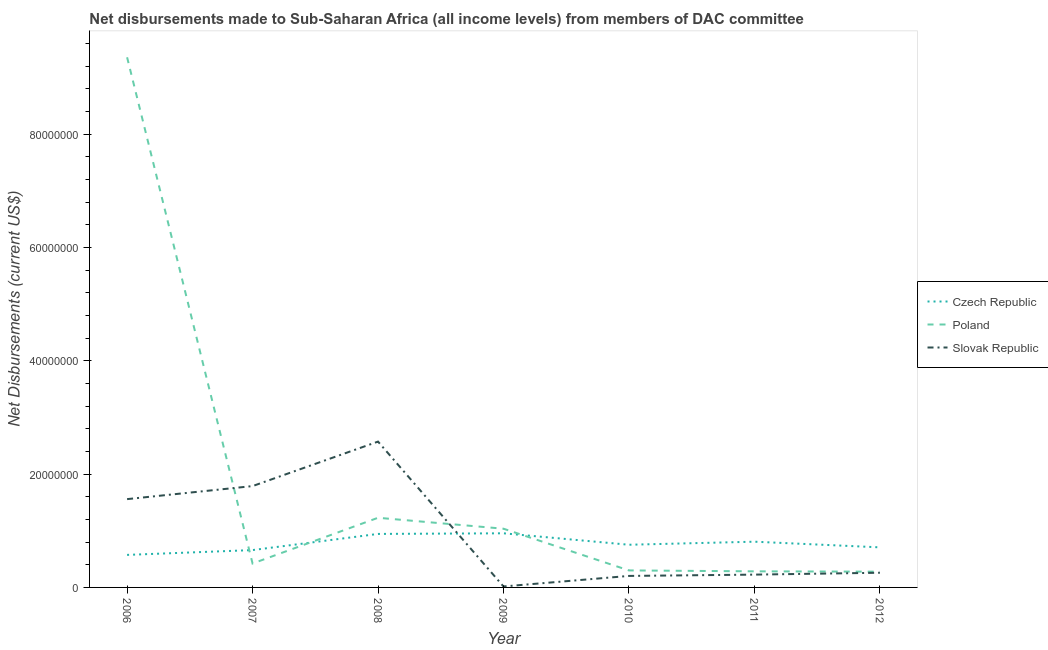Does the line corresponding to net disbursements made by slovak republic intersect with the line corresponding to net disbursements made by poland?
Your answer should be compact. Yes. What is the net disbursements made by poland in 2010?
Your answer should be very brief. 3.00e+06. Across all years, what is the maximum net disbursements made by poland?
Offer a very short reply. 9.35e+07. Across all years, what is the minimum net disbursements made by czech republic?
Your response must be concise. 5.74e+06. In which year was the net disbursements made by poland minimum?
Give a very brief answer. 2012. What is the total net disbursements made by slovak republic in the graph?
Keep it short and to the point. 6.62e+07. What is the difference between the net disbursements made by slovak republic in 2008 and that in 2012?
Your answer should be compact. 2.31e+07. What is the difference between the net disbursements made by poland in 2010 and the net disbursements made by czech republic in 2011?
Your response must be concise. -5.07e+06. What is the average net disbursements made by poland per year?
Your response must be concise. 1.84e+07. In the year 2006, what is the difference between the net disbursements made by czech republic and net disbursements made by slovak republic?
Keep it short and to the point. -9.84e+06. What is the ratio of the net disbursements made by slovak republic in 2007 to that in 2008?
Keep it short and to the point. 0.69. Is the difference between the net disbursements made by czech republic in 2006 and 2012 greater than the difference between the net disbursements made by slovak republic in 2006 and 2012?
Provide a succinct answer. No. What is the difference between the highest and the second highest net disbursements made by slovak republic?
Give a very brief answer. 7.85e+06. What is the difference between the highest and the lowest net disbursements made by poland?
Keep it short and to the point. 9.08e+07. In how many years, is the net disbursements made by czech republic greater than the average net disbursements made by czech republic taken over all years?
Your answer should be very brief. 3. Does the net disbursements made by slovak republic monotonically increase over the years?
Offer a terse response. No. Is the net disbursements made by slovak republic strictly greater than the net disbursements made by czech republic over the years?
Provide a short and direct response. No. Is the net disbursements made by slovak republic strictly less than the net disbursements made by czech republic over the years?
Offer a very short reply. No. How many years are there in the graph?
Your answer should be compact. 7. What is the difference between two consecutive major ticks on the Y-axis?
Your answer should be compact. 2.00e+07. Are the values on the major ticks of Y-axis written in scientific E-notation?
Keep it short and to the point. No. Does the graph contain any zero values?
Keep it short and to the point. No. How many legend labels are there?
Offer a terse response. 3. What is the title of the graph?
Your answer should be compact. Net disbursements made to Sub-Saharan Africa (all income levels) from members of DAC committee. What is the label or title of the Y-axis?
Offer a terse response. Net Disbursements (current US$). What is the Net Disbursements (current US$) in Czech Republic in 2006?
Keep it short and to the point. 5.74e+06. What is the Net Disbursements (current US$) in Poland in 2006?
Ensure brevity in your answer.  9.35e+07. What is the Net Disbursements (current US$) in Slovak Republic in 2006?
Provide a short and direct response. 1.56e+07. What is the Net Disbursements (current US$) in Czech Republic in 2007?
Your answer should be very brief. 6.59e+06. What is the Net Disbursements (current US$) in Poland in 2007?
Provide a succinct answer. 4.22e+06. What is the Net Disbursements (current US$) of Slovak Republic in 2007?
Offer a terse response. 1.79e+07. What is the Net Disbursements (current US$) of Czech Republic in 2008?
Make the answer very short. 9.44e+06. What is the Net Disbursements (current US$) in Poland in 2008?
Make the answer very short. 1.23e+07. What is the Net Disbursements (current US$) of Slovak Republic in 2008?
Offer a terse response. 2.57e+07. What is the Net Disbursements (current US$) in Czech Republic in 2009?
Keep it short and to the point. 9.55e+06. What is the Net Disbursements (current US$) of Poland in 2009?
Provide a short and direct response. 1.04e+07. What is the Net Disbursements (current US$) in Slovak Republic in 2009?
Ensure brevity in your answer.  1.70e+05. What is the Net Disbursements (current US$) in Czech Republic in 2010?
Offer a very short reply. 7.53e+06. What is the Net Disbursements (current US$) of Slovak Republic in 2010?
Offer a terse response. 2.03e+06. What is the Net Disbursements (current US$) in Czech Republic in 2011?
Provide a succinct answer. 8.07e+06. What is the Net Disbursements (current US$) of Poland in 2011?
Provide a short and direct response. 2.84e+06. What is the Net Disbursements (current US$) in Slovak Republic in 2011?
Your answer should be compact. 2.26e+06. What is the Net Disbursements (current US$) in Czech Republic in 2012?
Keep it short and to the point. 7.07e+06. What is the Net Disbursements (current US$) of Poland in 2012?
Your response must be concise. 2.78e+06. What is the Net Disbursements (current US$) of Slovak Republic in 2012?
Provide a succinct answer. 2.59e+06. Across all years, what is the maximum Net Disbursements (current US$) in Czech Republic?
Give a very brief answer. 9.55e+06. Across all years, what is the maximum Net Disbursements (current US$) of Poland?
Make the answer very short. 9.35e+07. Across all years, what is the maximum Net Disbursements (current US$) of Slovak Republic?
Your answer should be very brief. 2.57e+07. Across all years, what is the minimum Net Disbursements (current US$) in Czech Republic?
Your answer should be compact. 5.74e+06. Across all years, what is the minimum Net Disbursements (current US$) of Poland?
Provide a succinct answer. 2.78e+06. Across all years, what is the minimum Net Disbursements (current US$) in Slovak Republic?
Offer a very short reply. 1.70e+05. What is the total Net Disbursements (current US$) in Czech Republic in the graph?
Offer a terse response. 5.40e+07. What is the total Net Disbursements (current US$) of Poland in the graph?
Your answer should be compact. 1.29e+08. What is the total Net Disbursements (current US$) of Slovak Republic in the graph?
Give a very brief answer. 6.62e+07. What is the difference between the Net Disbursements (current US$) in Czech Republic in 2006 and that in 2007?
Your response must be concise. -8.50e+05. What is the difference between the Net Disbursements (current US$) of Poland in 2006 and that in 2007?
Your response must be concise. 8.93e+07. What is the difference between the Net Disbursements (current US$) in Slovak Republic in 2006 and that in 2007?
Give a very brief answer. -2.30e+06. What is the difference between the Net Disbursements (current US$) in Czech Republic in 2006 and that in 2008?
Provide a short and direct response. -3.70e+06. What is the difference between the Net Disbursements (current US$) of Poland in 2006 and that in 2008?
Offer a terse response. 8.12e+07. What is the difference between the Net Disbursements (current US$) of Slovak Republic in 2006 and that in 2008?
Your answer should be very brief. -1.02e+07. What is the difference between the Net Disbursements (current US$) in Czech Republic in 2006 and that in 2009?
Ensure brevity in your answer.  -3.81e+06. What is the difference between the Net Disbursements (current US$) of Poland in 2006 and that in 2009?
Your answer should be compact. 8.32e+07. What is the difference between the Net Disbursements (current US$) of Slovak Republic in 2006 and that in 2009?
Ensure brevity in your answer.  1.54e+07. What is the difference between the Net Disbursements (current US$) in Czech Republic in 2006 and that in 2010?
Your response must be concise. -1.79e+06. What is the difference between the Net Disbursements (current US$) in Poland in 2006 and that in 2010?
Offer a very short reply. 9.05e+07. What is the difference between the Net Disbursements (current US$) in Slovak Republic in 2006 and that in 2010?
Offer a terse response. 1.36e+07. What is the difference between the Net Disbursements (current US$) of Czech Republic in 2006 and that in 2011?
Your answer should be very brief. -2.33e+06. What is the difference between the Net Disbursements (current US$) of Poland in 2006 and that in 2011?
Provide a succinct answer. 9.07e+07. What is the difference between the Net Disbursements (current US$) of Slovak Republic in 2006 and that in 2011?
Provide a short and direct response. 1.33e+07. What is the difference between the Net Disbursements (current US$) of Czech Republic in 2006 and that in 2012?
Your response must be concise. -1.33e+06. What is the difference between the Net Disbursements (current US$) in Poland in 2006 and that in 2012?
Make the answer very short. 9.08e+07. What is the difference between the Net Disbursements (current US$) in Slovak Republic in 2006 and that in 2012?
Ensure brevity in your answer.  1.30e+07. What is the difference between the Net Disbursements (current US$) in Czech Republic in 2007 and that in 2008?
Give a very brief answer. -2.85e+06. What is the difference between the Net Disbursements (current US$) in Poland in 2007 and that in 2008?
Your answer should be very brief. -8.07e+06. What is the difference between the Net Disbursements (current US$) of Slovak Republic in 2007 and that in 2008?
Provide a short and direct response. -7.85e+06. What is the difference between the Net Disbursements (current US$) of Czech Republic in 2007 and that in 2009?
Give a very brief answer. -2.96e+06. What is the difference between the Net Disbursements (current US$) in Poland in 2007 and that in 2009?
Your answer should be very brief. -6.14e+06. What is the difference between the Net Disbursements (current US$) in Slovak Republic in 2007 and that in 2009?
Ensure brevity in your answer.  1.77e+07. What is the difference between the Net Disbursements (current US$) of Czech Republic in 2007 and that in 2010?
Provide a succinct answer. -9.40e+05. What is the difference between the Net Disbursements (current US$) of Poland in 2007 and that in 2010?
Provide a succinct answer. 1.22e+06. What is the difference between the Net Disbursements (current US$) of Slovak Republic in 2007 and that in 2010?
Make the answer very short. 1.58e+07. What is the difference between the Net Disbursements (current US$) in Czech Republic in 2007 and that in 2011?
Provide a succinct answer. -1.48e+06. What is the difference between the Net Disbursements (current US$) of Poland in 2007 and that in 2011?
Provide a succinct answer. 1.38e+06. What is the difference between the Net Disbursements (current US$) of Slovak Republic in 2007 and that in 2011?
Keep it short and to the point. 1.56e+07. What is the difference between the Net Disbursements (current US$) of Czech Republic in 2007 and that in 2012?
Ensure brevity in your answer.  -4.80e+05. What is the difference between the Net Disbursements (current US$) in Poland in 2007 and that in 2012?
Your response must be concise. 1.44e+06. What is the difference between the Net Disbursements (current US$) in Slovak Republic in 2007 and that in 2012?
Offer a terse response. 1.53e+07. What is the difference between the Net Disbursements (current US$) in Czech Republic in 2008 and that in 2009?
Provide a succinct answer. -1.10e+05. What is the difference between the Net Disbursements (current US$) of Poland in 2008 and that in 2009?
Give a very brief answer. 1.93e+06. What is the difference between the Net Disbursements (current US$) in Slovak Republic in 2008 and that in 2009?
Offer a terse response. 2.56e+07. What is the difference between the Net Disbursements (current US$) of Czech Republic in 2008 and that in 2010?
Keep it short and to the point. 1.91e+06. What is the difference between the Net Disbursements (current US$) of Poland in 2008 and that in 2010?
Your answer should be compact. 9.29e+06. What is the difference between the Net Disbursements (current US$) in Slovak Republic in 2008 and that in 2010?
Ensure brevity in your answer.  2.37e+07. What is the difference between the Net Disbursements (current US$) of Czech Republic in 2008 and that in 2011?
Your response must be concise. 1.37e+06. What is the difference between the Net Disbursements (current US$) of Poland in 2008 and that in 2011?
Provide a succinct answer. 9.45e+06. What is the difference between the Net Disbursements (current US$) in Slovak Republic in 2008 and that in 2011?
Give a very brief answer. 2.35e+07. What is the difference between the Net Disbursements (current US$) in Czech Republic in 2008 and that in 2012?
Your answer should be very brief. 2.37e+06. What is the difference between the Net Disbursements (current US$) in Poland in 2008 and that in 2012?
Give a very brief answer. 9.51e+06. What is the difference between the Net Disbursements (current US$) in Slovak Republic in 2008 and that in 2012?
Your answer should be compact. 2.31e+07. What is the difference between the Net Disbursements (current US$) in Czech Republic in 2009 and that in 2010?
Provide a succinct answer. 2.02e+06. What is the difference between the Net Disbursements (current US$) of Poland in 2009 and that in 2010?
Offer a very short reply. 7.36e+06. What is the difference between the Net Disbursements (current US$) in Slovak Republic in 2009 and that in 2010?
Provide a short and direct response. -1.86e+06. What is the difference between the Net Disbursements (current US$) in Czech Republic in 2009 and that in 2011?
Offer a very short reply. 1.48e+06. What is the difference between the Net Disbursements (current US$) in Poland in 2009 and that in 2011?
Your answer should be compact. 7.52e+06. What is the difference between the Net Disbursements (current US$) in Slovak Republic in 2009 and that in 2011?
Give a very brief answer. -2.09e+06. What is the difference between the Net Disbursements (current US$) in Czech Republic in 2009 and that in 2012?
Give a very brief answer. 2.48e+06. What is the difference between the Net Disbursements (current US$) in Poland in 2009 and that in 2012?
Offer a very short reply. 7.58e+06. What is the difference between the Net Disbursements (current US$) in Slovak Republic in 2009 and that in 2012?
Provide a short and direct response. -2.42e+06. What is the difference between the Net Disbursements (current US$) of Czech Republic in 2010 and that in 2011?
Offer a very short reply. -5.40e+05. What is the difference between the Net Disbursements (current US$) of Poland in 2010 and that in 2012?
Your answer should be compact. 2.20e+05. What is the difference between the Net Disbursements (current US$) in Slovak Republic in 2010 and that in 2012?
Ensure brevity in your answer.  -5.60e+05. What is the difference between the Net Disbursements (current US$) in Czech Republic in 2011 and that in 2012?
Give a very brief answer. 1.00e+06. What is the difference between the Net Disbursements (current US$) of Poland in 2011 and that in 2012?
Keep it short and to the point. 6.00e+04. What is the difference between the Net Disbursements (current US$) of Slovak Republic in 2011 and that in 2012?
Ensure brevity in your answer.  -3.30e+05. What is the difference between the Net Disbursements (current US$) in Czech Republic in 2006 and the Net Disbursements (current US$) in Poland in 2007?
Give a very brief answer. 1.52e+06. What is the difference between the Net Disbursements (current US$) in Czech Republic in 2006 and the Net Disbursements (current US$) in Slovak Republic in 2007?
Make the answer very short. -1.21e+07. What is the difference between the Net Disbursements (current US$) in Poland in 2006 and the Net Disbursements (current US$) in Slovak Republic in 2007?
Provide a succinct answer. 7.57e+07. What is the difference between the Net Disbursements (current US$) of Czech Republic in 2006 and the Net Disbursements (current US$) of Poland in 2008?
Offer a terse response. -6.55e+06. What is the difference between the Net Disbursements (current US$) in Czech Republic in 2006 and the Net Disbursements (current US$) in Slovak Republic in 2008?
Keep it short and to the point. -2.00e+07. What is the difference between the Net Disbursements (current US$) of Poland in 2006 and the Net Disbursements (current US$) of Slovak Republic in 2008?
Your response must be concise. 6.78e+07. What is the difference between the Net Disbursements (current US$) in Czech Republic in 2006 and the Net Disbursements (current US$) in Poland in 2009?
Offer a terse response. -4.62e+06. What is the difference between the Net Disbursements (current US$) of Czech Republic in 2006 and the Net Disbursements (current US$) of Slovak Republic in 2009?
Keep it short and to the point. 5.57e+06. What is the difference between the Net Disbursements (current US$) of Poland in 2006 and the Net Disbursements (current US$) of Slovak Republic in 2009?
Keep it short and to the point. 9.34e+07. What is the difference between the Net Disbursements (current US$) of Czech Republic in 2006 and the Net Disbursements (current US$) of Poland in 2010?
Your response must be concise. 2.74e+06. What is the difference between the Net Disbursements (current US$) in Czech Republic in 2006 and the Net Disbursements (current US$) in Slovak Republic in 2010?
Make the answer very short. 3.71e+06. What is the difference between the Net Disbursements (current US$) of Poland in 2006 and the Net Disbursements (current US$) of Slovak Republic in 2010?
Ensure brevity in your answer.  9.15e+07. What is the difference between the Net Disbursements (current US$) in Czech Republic in 2006 and the Net Disbursements (current US$) in Poland in 2011?
Give a very brief answer. 2.90e+06. What is the difference between the Net Disbursements (current US$) of Czech Republic in 2006 and the Net Disbursements (current US$) of Slovak Republic in 2011?
Give a very brief answer. 3.48e+06. What is the difference between the Net Disbursements (current US$) of Poland in 2006 and the Net Disbursements (current US$) of Slovak Republic in 2011?
Offer a terse response. 9.13e+07. What is the difference between the Net Disbursements (current US$) in Czech Republic in 2006 and the Net Disbursements (current US$) in Poland in 2012?
Ensure brevity in your answer.  2.96e+06. What is the difference between the Net Disbursements (current US$) of Czech Republic in 2006 and the Net Disbursements (current US$) of Slovak Republic in 2012?
Your answer should be compact. 3.15e+06. What is the difference between the Net Disbursements (current US$) in Poland in 2006 and the Net Disbursements (current US$) in Slovak Republic in 2012?
Your answer should be compact. 9.10e+07. What is the difference between the Net Disbursements (current US$) in Czech Republic in 2007 and the Net Disbursements (current US$) in Poland in 2008?
Your response must be concise. -5.70e+06. What is the difference between the Net Disbursements (current US$) in Czech Republic in 2007 and the Net Disbursements (current US$) in Slovak Republic in 2008?
Give a very brief answer. -1.91e+07. What is the difference between the Net Disbursements (current US$) of Poland in 2007 and the Net Disbursements (current US$) of Slovak Republic in 2008?
Provide a short and direct response. -2.15e+07. What is the difference between the Net Disbursements (current US$) in Czech Republic in 2007 and the Net Disbursements (current US$) in Poland in 2009?
Provide a succinct answer. -3.77e+06. What is the difference between the Net Disbursements (current US$) in Czech Republic in 2007 and the Net Disbursements (current US$) in Slovak Republic in 2009?
Offer a very short reply. 6.42e+06. What is the difference between the Net Disbursements (current US$) in Poland in 2007 and the Net Disbursements (current US$) in Slovak Republic in 2009?
Give a very brief answer. 4.05e+06. What is the difference between the Net Disbursements (current US$) in Czech Republic in 2007 and the Net Disbursements (current US$) in Poland in 2010?
Offer a very short reply. 3.59e+06. What is the difference between the Net Disbursements (current US$) in Czech Republic in 2007 and the Net Disbursements (current US$) in Slovak Republic in 2010?
Offer a terse response. 4.56e+06. What is the difference between the Net Disbursements (current US$) in Poland in 2007 and the Net Disbursements (current US$) in Slovak Republic in 2010?
Keep it short and to the point. 2.19e+06. What is the difference between the Net Disbursements (current US$) of Czech Republic in 2007 and the Net Disbursements (current US$) of Poland in 2011?
Provide a short and direct response. 3.75e+06. What is the difference between the Net Disbursements (current US$) in Czech Republic in 2007 and the Net Disbursements (current US$) in Slovak Republic in 2011?
Offer a terse response. 4.33e+06. What is the difference between the Net Disbursements (current US$) in Poland in 2007 and the Net Disbursements (current US$) in Slovak Republic in 2011?
Offer a terse response. 1.96e+06. What is the difference between the Net Disbursements (current US$) of Czech Republic in 2007 and the Net Disbursements (current US$) of Poland in 2012?
Ensure brevity in your answer.  3.81e+06. What is the difference between the Net Disbursements (current US$) of Czech Republic in 2007 and the Net Disbursements (current US$) of Slovak Republic in 2012?
Your answer should be compact. 4.00e+06. What is the difference between the Net Disbursements (current US$) of Poland in 2007 and the Net Disbursements (current US$) of Slovak Republic in 2012?
Your answer should be compact. 1.63e+06. What is the difference between the Net Disbursements (current US$) of Czech Republic in 2008 and the Net Disbursements (current US$) of Poland in 2009?
Your response must be concise. -9.20e+05. What is the difference between the Net Disbursements (current US$) of Czech Republic in 2008 and the Net Disbursements (current US$) of Slovak Republic in 2009?
Your answer should be compact. 9.27e+06. What is the difference between the Net Disbursements (current US$) in Poland in 2008 and the Net Disbursements (current US$) in Slovak Republic in 2009?
Make the answer very short. 1.21e+07. What is the difference between the Net Disbursements (current US$) of Czech Republic in 2008 and the Net Disbursements (current US$) of Poland in 2010?
Provide a succinct answer. 6.44e+06. What is the difference between the Net Disbursements (current US$) of Czech Republic in 2008 and the Net Disbursements (current US$) of Slovak Republic in 2010?
Your answer should be compact. 7.41e+06. What is the difference between the Net Disbursements (current US$) of Poland in 2008 and the Net Disbursements (current US$) of Slovak Republic in 2010?
Give a very brief answer. 1.03e+07. What is the difference between the Net Disbursements (current US$) of Czech Republic in 2008 and the Net Disbursements (current US$) of Poland in 2011?
Provide a short and direct response. 6.60e+06. What is the difference between the Net Disbursements (current US$) of Czech Republic in 2008 and the Net Disbursements (current US$) of Slovak Republic in 2011?
Your answer should be compact. 7.18e+06. What is the difference between the Net Disbursements (current US$) in Poland in 2008 and the Net Disbursements (current US$) in Slovak Republic in 2011?
Your answer should be very brief. 1.00e+07. What is the difference between the Net Disbursements (current US$) of Czech Republic in 2008 and the Net Disbursements (current US$) of Poland in 2012?
Offer a terse response. 6.66e+06. What is the difference between the Net Disbursements (current US$) of Czech Republic in 2008 and the Net Disbursements (current US$) of Slovak Republic in 2012?
Offer a very short reply. 6.85e+06. What is the difference between the Net Disbursements (current US$) in Poland in 2008 and the Net Disbursements (current US$) in Slovak Republic in 2012?
Ensure brevity in your answer.  9.70e+06. What is the difference between the Net Disbursements (current US$) in Czech Republic in 2009 and the Net Disbursements (current US$) in Poland in 2010?
Give a very brief answer. 6.55e+06. What is the difference between the Net Disbursements (current US$) in Czech Republic in 2009 and the Net Disbursements (current US$) in Slovak Republic in 2010?
Your answer should be very brief. 7.52e+06. What is the difference between the Net Disbursements (current US$) in Poland in 2009 and the Net Disbursements (current US$) in Slovak Republic in 2010?
Give a very brief answer. 8.33e+06. What is the difference between the Net Disbursements (current US$) in Czech Republic in 2009 and the Net Disbursements (current US$) in Poland in 2011?
Your answer should be compact. 6.71e+06. What is the difference between the Net Disbursements (current US$) of Czech Republic in 2009 and the Net Disbursements (current US$) of Slovak Republic in 2011?
Provide a short and direct response. 7.29e+06. What is the difference between the Net Disbursements (current US$) of Poland in 2009 and the Net Disbursements (current US$) of Slovak Republic in 2011?
Your answer should be compact. 8.10e+06. What is the difference between the Net Disbursements (current US$) in Czech Republic in 2009 and the Net Disbursements (current US$) in Poland in 2012?
Keep it short and to the point. 6.77e+06. What is the difference between the Net Disbursements (current US$) in Czech Republic in 2009 and the Net Disbursements (current US$) in Slovak Republic in 2012?
Provide a succinct answer. 6.96e+06. What is the difference between the Net Disbursements (current US$) in Poland in 2009 and the Net Disbursements (current US$) in Slovak Republic in 2012?
Ensure brevity in your answer.  7.77e+06. What is the difference between the Net Disbursements (current US$) of Czech Republic in 2010 and the Net Disbursements (current US$) of Poland in 2011?
Your answer should be very brief. 4.69e+06. What is the difference between the Net Disbursements (current US$) of Czech Republic in 2010 and the Net Disbursements (current US$) of Slovak Republic in 2011?
Your answer should be very brief. 5.27e+06. What is the difference between the Net Disbursements (current US$) in Poland in 2010 and the Net Disbursements (current US$) in Slovak Republic in 2011?
Provide a succinct answer. 7.40e+05. What is the difference between the Net Disbursements (current US$) of Czech Republic in 2010 and the Net Disbursements (current US$) of Poland in 2012?
Your response must be concise. 4.75e+06. What is the difference between the Net Disbursements (current US$) of Czech Republic in 2010 and the Net Disbursements (current US$) of Slovak Republic in 2012?
Give a very brief answer. 4.94e+06. What is the difference between the Net Disbursements (current US$) of Poland in 2010 and the Net Disbursements (current US$) of Slovak Republic in 2012?
Your answer should be compact. 4.10e+05. What is the difference between the Net Disbursements (current US$) in Czech Republic in 2011 and the Net Disbursements (current US$) in Poland in 2012?
Offer a very short reply. 5.29e+06. What is the difference between the Net Disbursements (current US$) in Czech Republic in 2011 and the Net Disbursements (current US$) in Slovak Republic in 2012?
Your response must be concise. 5.48e+06. What is the difference between the Net Disbursements (current US$) of Poland in 2011 and the Net Disbursements (current US$) of Slovak Republic in 2012?
Provide a succinct answer. 2.50e+05. What is the average Net Disbursements (current US$) in Czech Republic per year?
Ensure brevity in your answer.  7.71e+06. What is the average Net Disbursements (current US$) in Poland per year?
Provide a short and direct response. 1.84e+07. What is the average Net Disbursements (current US$) in Slovak Republic per year?
Give a very brief answer. 9.46e+06. In the year 2006, what is the difference between the Net Disbursements (current US$) in Czech Republic and Net Disbursements (current US$) in Poland?
Your answer should be compact. -8.78e+07. In the year 2006, what is the difference between the Net Disbursements (current US$) in Czech Republic and Net Disbursements (current US$) in Slovak Republic?
Ensure brevity in your answer.  -9.84e+06. In the year 2006, what is the difference between the Net Disbursements (current US$) in Poland and Net Disbursements (current US$) in Slovak Republic?
Your answer should be compact. 7.80e+07. In the year 2007, what is the difference between the Net Disbursements (current US$) of Czech Republic and Net Disbursements (current US$) of Poland?
Give a very brief answer. 2.37e+06. In the year 2007, what is the difference between the Net Disbursements (current US$) in Czech Republic and Net Disbursements (current US$) in Slovak Republic?
Offer a very short reply. -1.13e+07. In the year 2007, what is the difference between the Net Disbursements (current US$) in Poland and Net Disbursements (current US$) in Slovak Republic?
Give a very brief answer. -1.37e+07. In the year 2008, what is the difference between the Net Disbursements (current US$) in Czech Republic and Net Disbursements (current US$) in Poland?
Your answer should be very brief. -2.85e+06. In the year 2008, what is the difference between the Net Disbursements (current US$) of Czech Republic and Net Disbursements (current US$) of Slovak Republic?
Your answer should be very brief. -1.63e+07. In the year 2008, what is the difference between the Net Disbursements (current US$) of Poland and Net Disbursements (current US$) of Slovak Republic?
Offer a terse response. -1.34e+07. In the year 2009, what is the difference between the Net Disbursements (current US$) in Czech Republic and Net Disbursements (current US$) in Poland?
Your answer should be compact. -8.10e+05. In the year 2009, what is the difference between the Net Disbursements (current US$) of Czech Republic and Net Disbursements (current US$) of Slovak Republic?
Offer a terse response. 9.38e+06. In the year 2009, what is the difference between the Net Disbursements (current US$) of Poland and Net Disbursements (current US$) of Slovak Republic?
Provide a short and direct response. 1.02e+07. In the year 2010, what is the difference between the Net Disbursements (current US$) in Czech Republic and Net Disbursements (current US$) in Poland?
Provide a short and direct response. 4.53e+06. In the year 2010, what is the difference between the Net Disbursements (current US$) in Czech Republic and Net Disbursements (current US$) in Slovak Republic?
Your answer should be very brief. 5.50e+06. In the year 2010, what is the difference between the Net Disbursements (current US$) in Poland and Net Disbursements (current US$) in Slovak Republic?
Give a very brief answer. 9.70e+05. In the year 2011, what is the difference between the Net Disbursements (current US$) of Czech Republic and Net Disbursements (current US$) of Poland?
Your response must be concise. 5.23e+06. In the year 2011, what is the difference between the Net Disbursements (current US$) of Czech Republic and Net Disbursements (current US$) of Slovak Republic?
Ensure brevity in your answer.  5.81e+06. In the year 2011, what is the difference between the Net Disbursements (current US$) in Poland and Net Disbursements (current US$) in Slovak Republic?
Give a very brief answer. 5.80e+05. In the year 2012, what is the difference between the Net Disbursements (current US$) of Czech Republic and Net Disbursements (current US$) of Poland?
Provide a succinct answer. 4.29e+06. In the year 2012, what is the difference between the Net Disbursements (current US$) in Czech Republic and Net Disbursements (current US$) in Slovak Republic?
Make the answer very short. 4.48e+06. In the year 2012, what is the difference between the Net Disbursements (current US$) of Poland and Net Disbursements (current US$) of Slovak Republic?
Give a very brief answer. 1.90e+05. What is the ratio of the Net Disbursements (current US$) in Czech Republic in 2006 to that in 2007?
Your answer should be compact. 0.87. What is the ratio of the Net Disbursements (current US$) in Poland in 2006 to that in 2007?
Make the answer very short. 22.17. What is the ratio of the Net Disbursements (current US$) in Slovak Republic in 2006 to that in 2007?
Your response must be concise. 0.87. What is the ratio of the Net Disbursements (current US$) of Czech Republic in 2006 to that in 2008?
Keep it short and to the point. 0.61. What is the ratio of the Net Disbursements (current US$) in Poland in 2006 to that in 2008?
Your response must be concise. 7.61. What is the ratio of the Net Disbursements (current US$) in Slovak Republic in 2006 to that in 2008?
Ensure brevity in your answer.  0.61. What is the ratio of the Net Disbursements (current US$) of Czech Republic in 2006 to that in 2009?
Offer a very short reply. 0.6. What is the ratio of the Net Disbursements (current US$) in Poland in 2006 to that in 2009?
Make the answer very short. 9.03. What is the ratio of the Net Disbursements (current US$) in Slovak Republic in 2006 to that in 2009?
Give a very brief answer. 91.65. What is the ratio of the Net Disbursements (current US$) in Czech Republic in 2006 to that in 2010?
Your answer should be very brief. 0.76. What is the ratio of the Net Disbursements (current US$) of Poland in 2006 to that in 2010?
Your answer should be very brief. 31.18. What is the ratio of the Net Disbursements (current US$) in Slovak Republic in 2006 to that in 2010?
Your response must be concise. 7.67. What is the ratio of the Net Disbursements (current US$) of Czech Republic in 2006 to that in 2011?
Provide a succinct answer. 0.71. What is the ratio of the Net Disbursements (current US$) in Poland in 2006 to that in 2011?
Offer a very short reply. 32.94. What is the ratio of the Net Disbursements (current US$) in Slovak Republic in 2006 to that in 2011?
Your answer should be very brief. 6.89. What is the ratio of the Net Disbursements (current US$) in Czech Republic in 2006 to that in 2012?
Your answer should be very brief. 0.81. What is the ratio of the Net Disbursements (current US$) of Poland in 2006 to that in 2012?
Your answer should be very brief. 33.65. What is the ratio of the Net Disbursements (current US$) in Slovak Republic in 2006 to that in 2012?
Your answer should be very brief. 6.02. What is the ratio of the Net Disbursements (current US$) in Czech Republic in 2007 to that in 2008?
Your answer should be very brief. 0.7. What is the ratio of the Net Disbursements (current US$) of Poland in 2007 to that in 2008?
Keep it short and to the point. 0.34. What is the ratio of the Net Disbursements (current US$) in Slovak Republic in 2007 to that in 2008?
Provide a succinct answer. 0.69. What is the ratio of the Net Disbursements (current US$) in Czech Republic in 2007 to that in 2009?
Make the answer very short. 0.69. What is the ratio of the Net Disbursements (current US$) in Poland in 2007 to that in 2009?
Your answer should be very brief. 0.41. What is the ratio of the Net Disbursements (current US$) in Slovak Republic in 2007 to that in 2009?
Your answer should be very brief. 105.18. What is the ratio of the Net Disbursements (current US$) of Czech Republic in 2007 to that in 2010?
Keep it short and to the point. 0.88. What is the ratio of the Net Disbursements (current US$) in Poland in 2007 to that in 2010?
Ensure brevity in your answer.  1.41. What is the ratio of the Net Disbursements (current US$) in Slovak Republic in 2007 to that in 2010?
Offer a very short reply. 8.81. What is the ratio of the Net Disbursements (current US$) of Czech Republic in 2007 to that in 2011?
Offer a terse response. 0.82. What is the ratio of the Net Disbursements (current US$) in Poland in 2007 to that in 2011?
Ensure brevity in your answer.  1.49. What is the ratio of the Net Disbursements (current US$) of Slovak Republic in 2007 to that in 2011?
Make the answer very short. 7.91. What is the ratio of the Net Disbursements (current US$) in Czech Republic in 2007 to that in 2012?
Offer a terse response. 0.93. What is the ratio of the Net Disbursements (current US$) of Poland in 2007 to that in 2012?
Provide a short and direct response. 1.52. What is the ratio of the Net Disbursements (current US$) in Slovak Republic in 2007 to that in 2012?
Your answer should be compact. 6.9. What is the ratio of the Net Disbursements (current US$) in Czech Republic in 2008 to that in 2009?
Ensure brevity in your answer.  0.99. What is the ratio of the Net Disbursements (current US$) of Poland in 2008 to that in 2009?
Make the answer very short. 1.19. What is the ratio of the Net Disbursements (current US$) in Slovak Republic in 2008 to that in 2009?
Ensure brevity in your answer.  151.35. What is the ratio of the Net Disbursements (current US$) of Czech Republic in 2008 to that in 2010?
Your answer should be very brief. 1.25. What is the ratio of the Net Disbursements (current US$) in Poland in 2008 to that in 2010?
Your response must be concise. 4.1. What is the ratio of the Net Disbursements (current US$) in Slovak Republic in 2008 to that in 2010?
Your answer should be compact. 12.67. What is the ratio of the Net Disbursements (current US$) in Czech Republic in 2008 to that in 2011?
Provide a short and direct response. 1.17. What is the ratio of the Net Disbursements (current US$) in Poland in 2008 to that in 2011?
Keep it short and to the point. 4.33. What is the ratio of the Net Disbursements (current US$) of Slovak Republic in 2008 to that in 2011?
Ensure brevity in your answer.  11.38. What is the ratio of the Net Disbursements (current US$) of Czech Republic in 2008 to that in 2012?
Make the answer very short. 1.34. What is the ratio of the Net Disbursements (current US$) in Poland in 2008 to that in 2012?
Make the answer very short. 4.42. What is the ratio of the Net Disbursements (current US$) in Slovak Republic in 2008 to that in 2012?
Provide a short and direct response. 9.93. What is the ratio of the Net Disbursements (current US$) of Czech Republic in 2009 to that in 2010?
Offer a terse response. 1.27. What is the ratio of the Net Disbursements (current US$) in Poland in 2009 to that in 2010?
Make the answer very short. 3.45. What is the ratio of the Net Disbursements (current US$) in Slovak Republic in 2009 to that in 2010?
Offer a terse response. 0.08. What is the ratio of the Net Disbursements (current US$) in Czech Republic in 2009 to that in 2011?
Offer a terse response. 1.18. What is the ratio of the Net Disbursements (current US$) of Poland in 2009 to that in 2011?
Provide a short and direct response. 3.65. What is the ratio of the Net Disbursements (current US$) of Slovak Republic in 2009 to that in 2011?
Offer a very short reply. 0.08. What is the ratio of the Net Disbursements (current US$) in Czech Republic in 2009 to that in 2012?
Give a very brief answer. 1.35. What is the ratio of the Net Disbursements (current US$) of Poland in 2009 to that in 2012?
Ensure brevity in your answer.  3.73. What is the ratio of the Net Disbursements (current US$) in Slovak Republic in 2009 to that in 2012?
Your response must be concise. 0.07. What is the ratio of the Net Disbursements (current US$) of Czech Republic in 2010 to that in 2011?
Offer a terse response. 0.93. What is the ratio of the Net Disbursements (current US$) in Poland in 2010 to that in 2011?
Your answer should be very brief. 1.06. What is the ratio of the Net Disbursements (current US$) of Slovak Republic in 2010 to that in 2011?
Your response must be concise. 0.9. What is the ratio of the Net Disbursements (current US$) of Czech Republic in 2010 to that in 2012?
Provide a succinct answer. 1.07. What is the ratio of the Net Disbursements (current US$) in Poland in 2010 to that in 2012?
Provide a succinct answer. 1.08. What is the ratio of the Net Disbursements (current US$) in Slovak Republic in 2010 to that in 2012?
Your response must be concise. 0.78. What is the ratio of the Net Disbursements (current US$) in Czech Republic in 2011 to that in 2012?
Ensure brevity in your answer.  1.14. What is the ratio of the Net Disbursements (current US$) in Poland in 2011 to that in 2012?
Give a very brief answer. 1.02. What is the ratio of the Net Disbursements (current US$) of Slovak Republic in 2011 to that in 2012?
Ensure brevity in your answer.  0.87. What is the difference between the highest and the second highest Net Disbursements (current US$) of Poland?
Your answer should be compact. 8.12e+07. What is the difference between the highest and the second highest Net Disbursements (current US$) in Slovak Republic?
Your answer should be very brief. 7.85e+06. What is the difference between the highest and the lowest Net Disbursements (current US$) of Czech Republic?
Give a very brief answer. 3.81e+06. What is the difference between the highest and the lowest Net Disbursements (current US$) in Poland?
Offer a very short reply. 9.08e+07. What is the difference between the highest and the lowest Net Disbursements (current US$) in Slovak Republic?
Your answer should be very brief. 2.56e+07. 